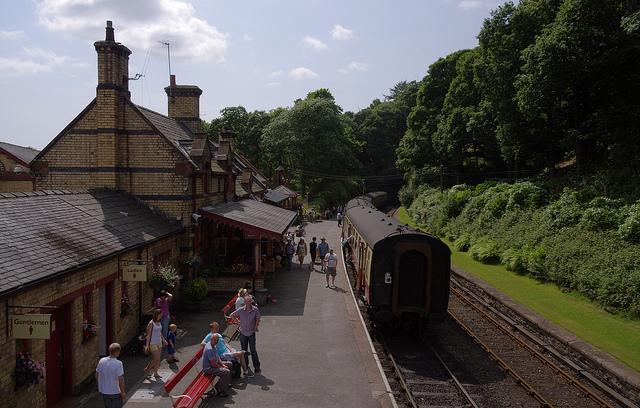In what direction will the train go next with respect to the person taking this person?

Choices:
A) south
B) north
C) south
D) east north 